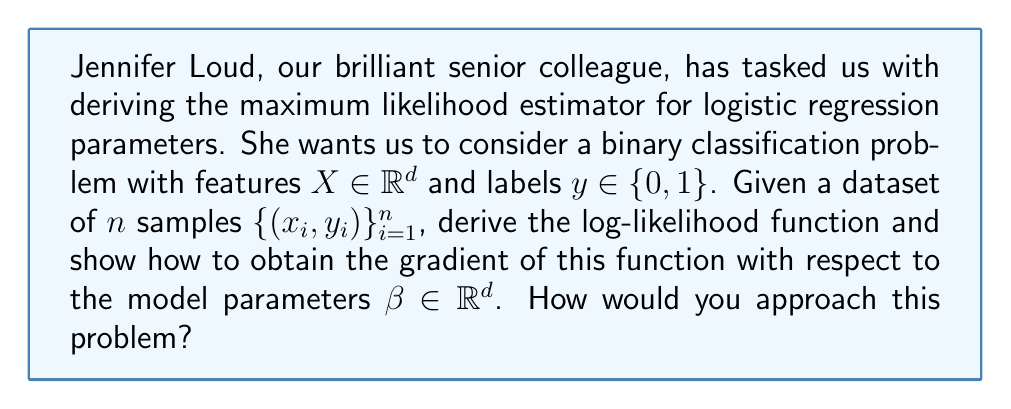Show me your answer to this math problem. Let's approach this problem step by step, following Jennifer Loud's guidance:

1) In logistic regression, we model the probability of the positive class (y = 1) given the features x as:

   $$P(y=1|x; \beta) = \frac{1}{1 + e^{-\beta^T x}} = \sigma(\beta^T x)$$

   where $\sigma(z) = \frac{1}{1 + e^{-z}}$ is the sigmoid function.

2) The likelihood function for the entire dataset is:

   $$L(\beta) = \prod_{i=1}^n P(y_i|x_i; \beta) = \prod_{i=1}^n \sigma(\beta^T x_i)^{y_i} (1 - \sigma(\beta^T x_i))^{1-y_i}$$

3) Taking the natural logarithm, we get the log-likelihood function:

   $$\ell(\beta) = \log L(\beta) = \sum_{i=1}^n [y_i \log(\sigma(\beta^T x_i)) + (1-y_i) \log(1 - \sigma(\beta^T x_i))]$$

4) To find the maximum likelihood estimator, we need to maximize this function. We can do this by finding where its gradient equals zero. The gradient with respect to $\beta$ is:

   $$\nabla_\beta \ell(\beta) = \sum_{i=1}^n [y_i - \sigma(\beta^T x_i)] x_i$$

5) This gradient can be derived using the chain rule and the fact that $\frac{d}{dz} \sigma(z) = \sigma(z)(1-\sigma(z))$.

6) Setting this gradient to zero gives us the maximum likelihood equation:

   $$\sum_{i=1}^n [y_i - \sigma(\beta^T x_i)] x_i = 0$$

7) This equation doesn't have a closed-form solution, so we typically use numerical optimization methods like gradient descent or Newton's method to find the optimal $\beta$.
Answer: The gradient of the log-likelihood function with respect to the model parameters $\beta$ is:

$$\nabla_\beta \ell(\beta) = \sum_{i=1}^n [y_i - \sigma(\beta^T x_i)] x_i$$

Where $\sigma(z) = \frac{1}{1 + e^{-z}}$ is the sigmoid function. This gradient is set to zero to find the maximum likelihood estimator, but the resulting equation must be solved numerically. 